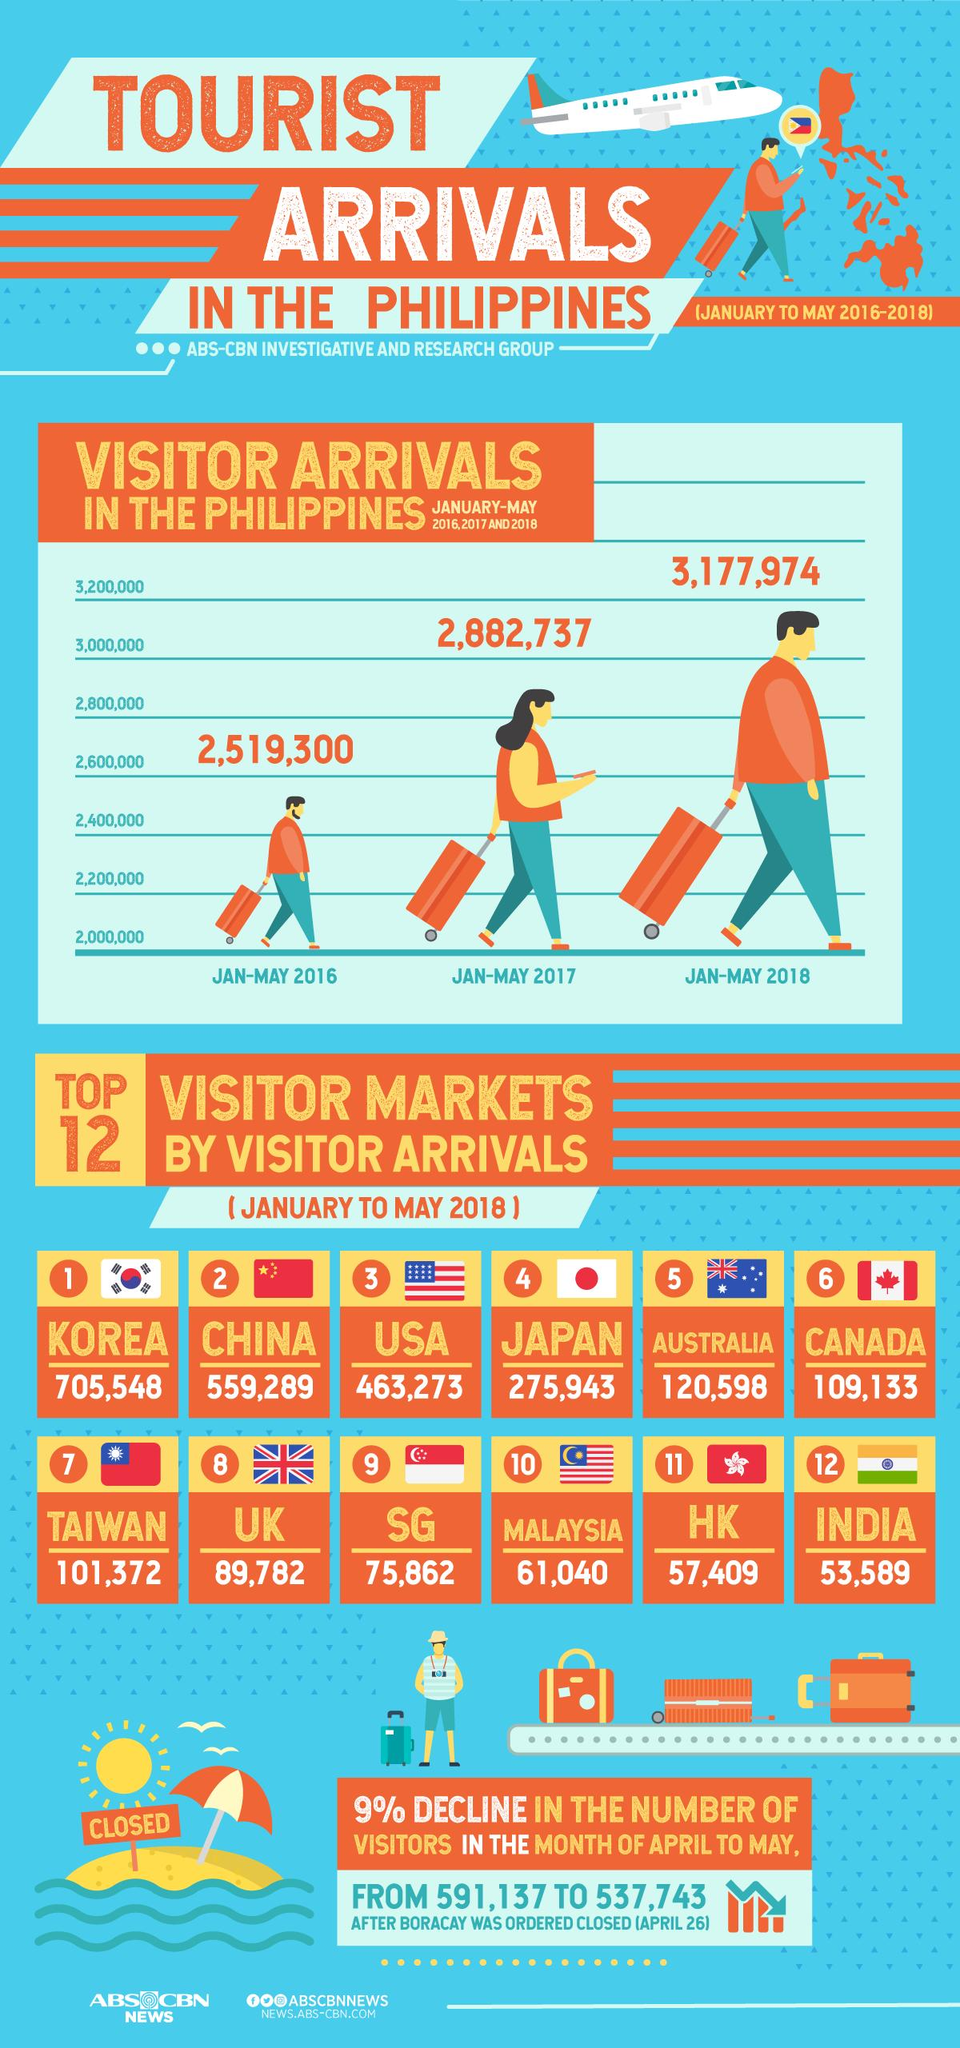List a handful of essential elements in this visual. The number of visitor arrivals in Korea and India, taken together, is 759137. The number of visitor arrivals in Japan and Singapore, taken together, is 351,805. The number of visitors who arrived in the period of January to May 2018 compared to the same period in 2017 is 295,237. The difference between the number of visitors who arrived in the first five months of 2017 and 2016, taken together, is 363,437. 